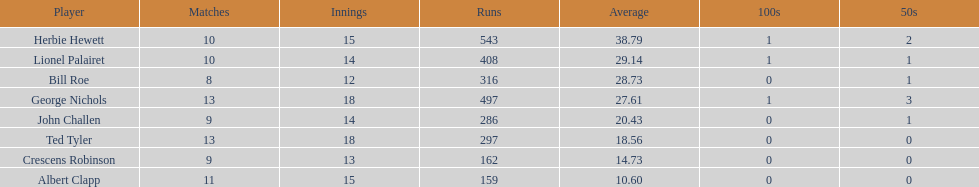What is the least about of runs anyone has? 159. 